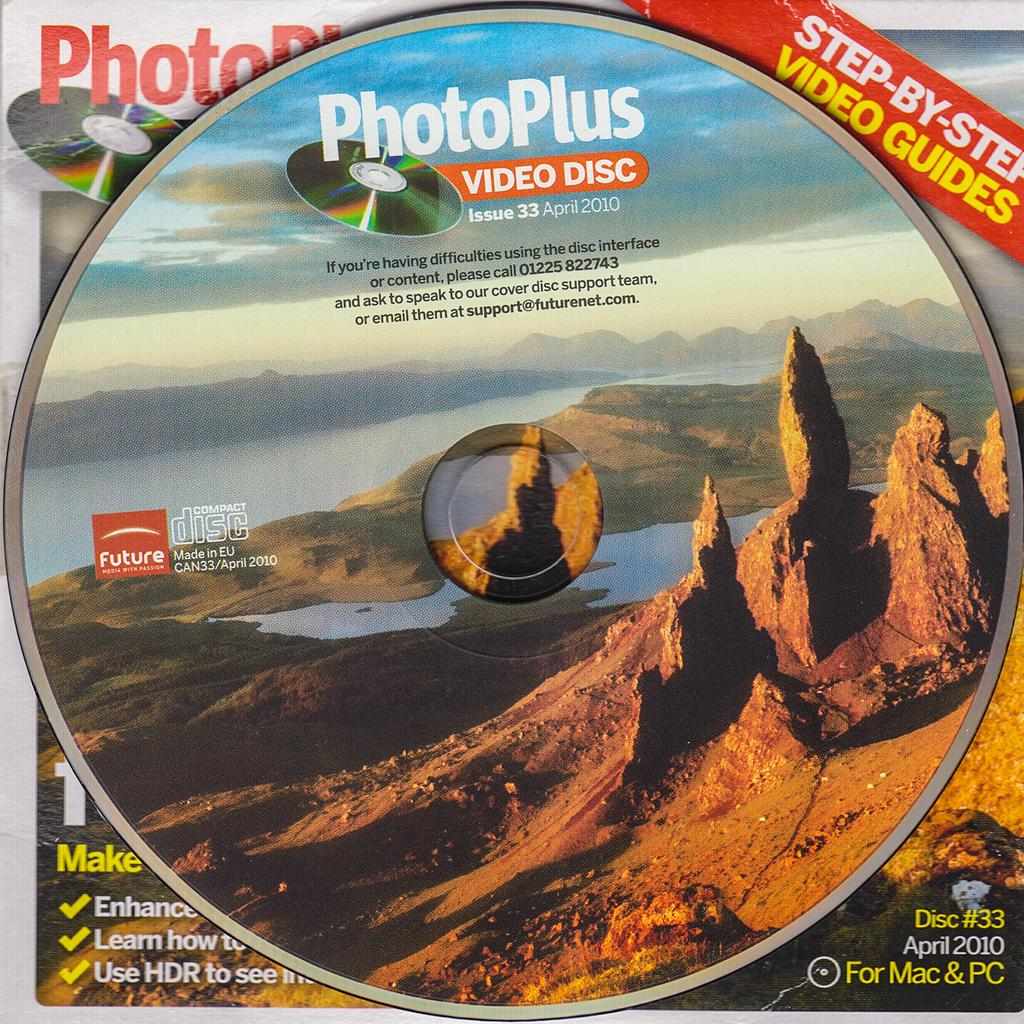<image>
Provide a brief description of the given image. A video disc from PhotoPlus was released in April of 2010. 